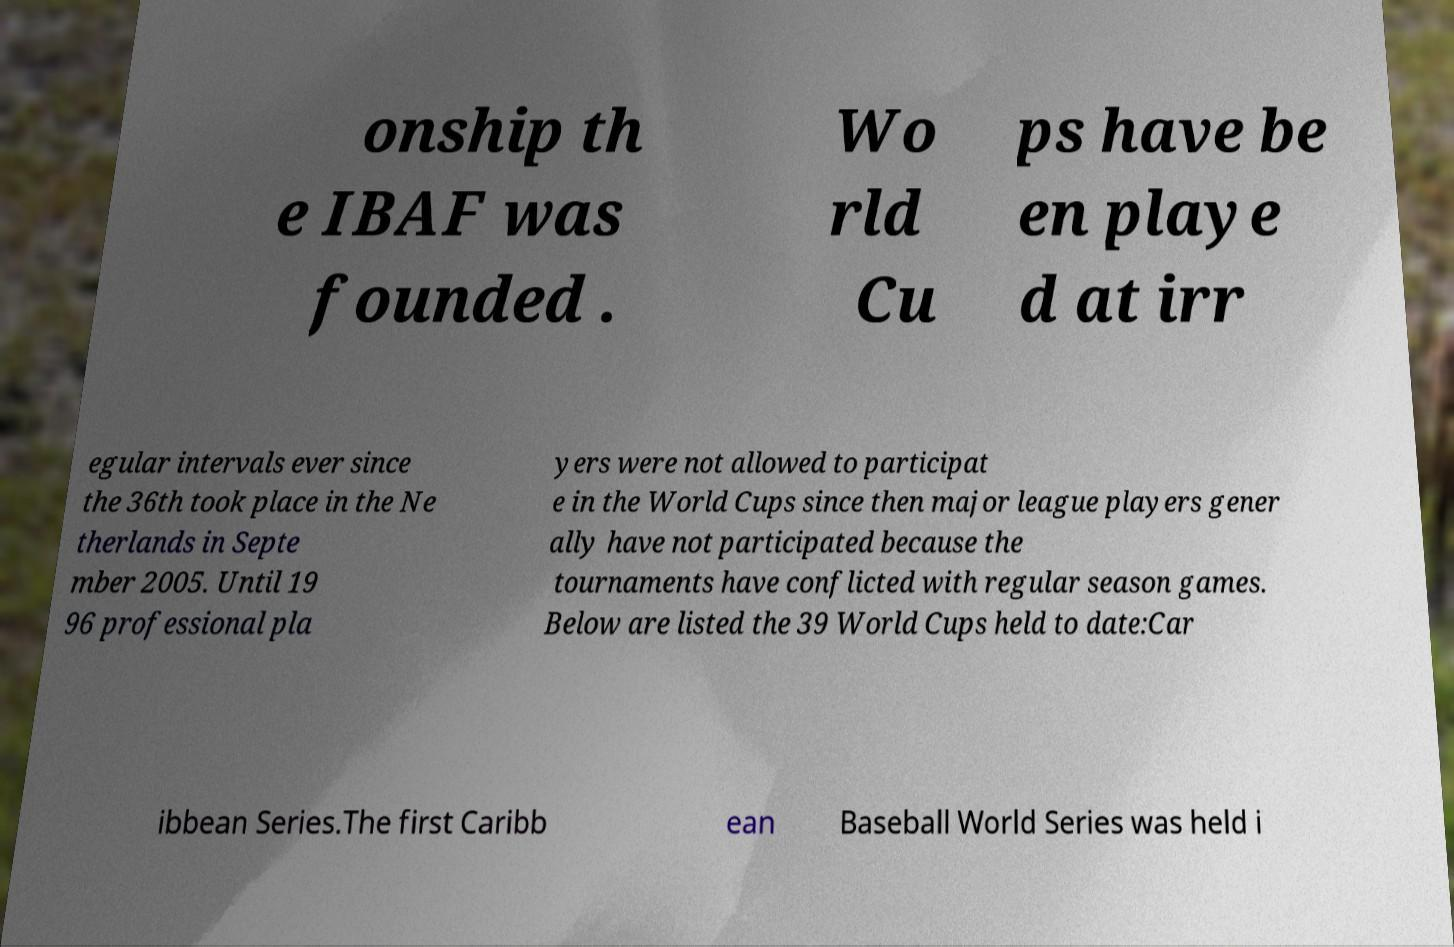Please identify and transcribe the text found in this image. onship th e IBAF was founded . Wo rld Cu ps have be en playe d at irr egular intervals ever since the 36th took place in the Ne therlands in Septe mber 2005. Until 19 96 professional pla yers were not allowed to participat e in the World Cups since then major league players gener ally have not participated because the tournaments have conflicted with regular season games. Below are listed the 39 World Cups held to date:Car ibbean Series.The first Caribb ean Baseball World Series was held i 